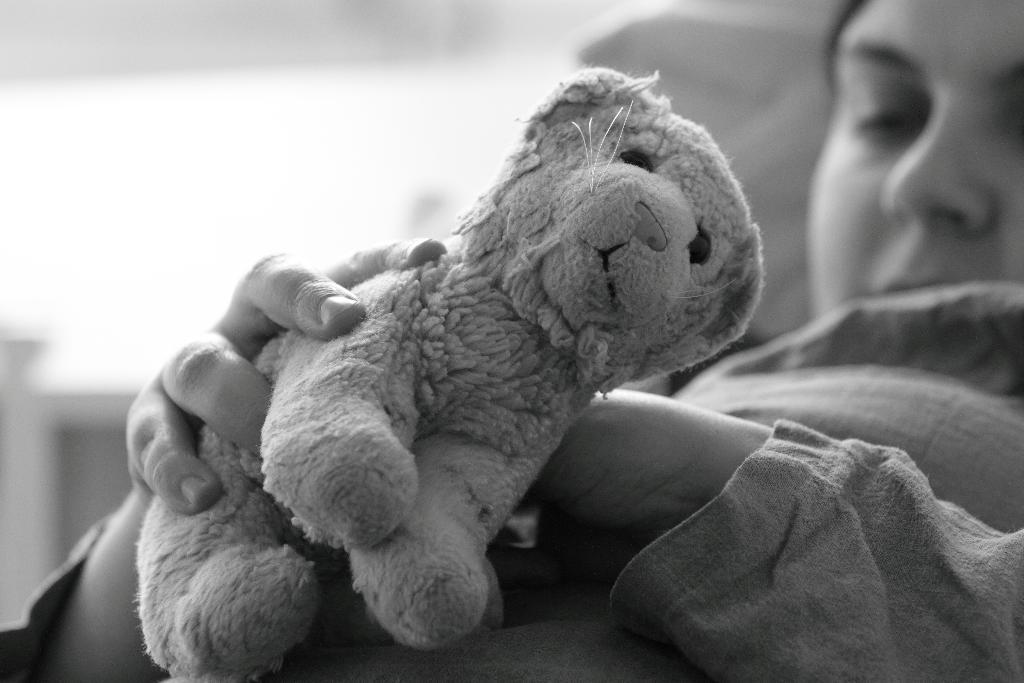Who is present in the image? There is a woman in the image. What is the woman holding in her hands? The woman is holding a toy in her hands. What type of cracker is the woman eating in the image? There is no cracker present in the image; the woman is holding a toy. Can you describe the road that the woman is walking on in the image? There is no road or walking depicted in the image; the woman is holding a toy. 